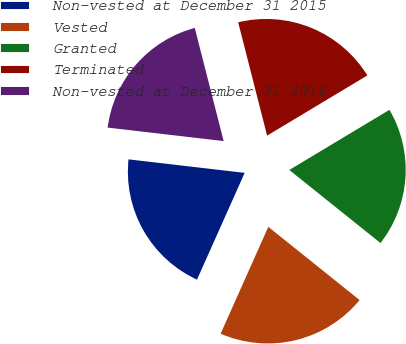Convert chart to OTSL. <chart><loc_0><loc_0><loc_500><loc_500><pie_chart><fcel>Non-vested at December 31 2015<fcel>Vested<fcel>Granted<fcel>Terminated<fcel>Non-vested at December 31 2016<nl><fcel>20.16%<fcel>20.93%<fcel>19.36%<fcel>20.37%<fcel>19.18%<nl></chart> 